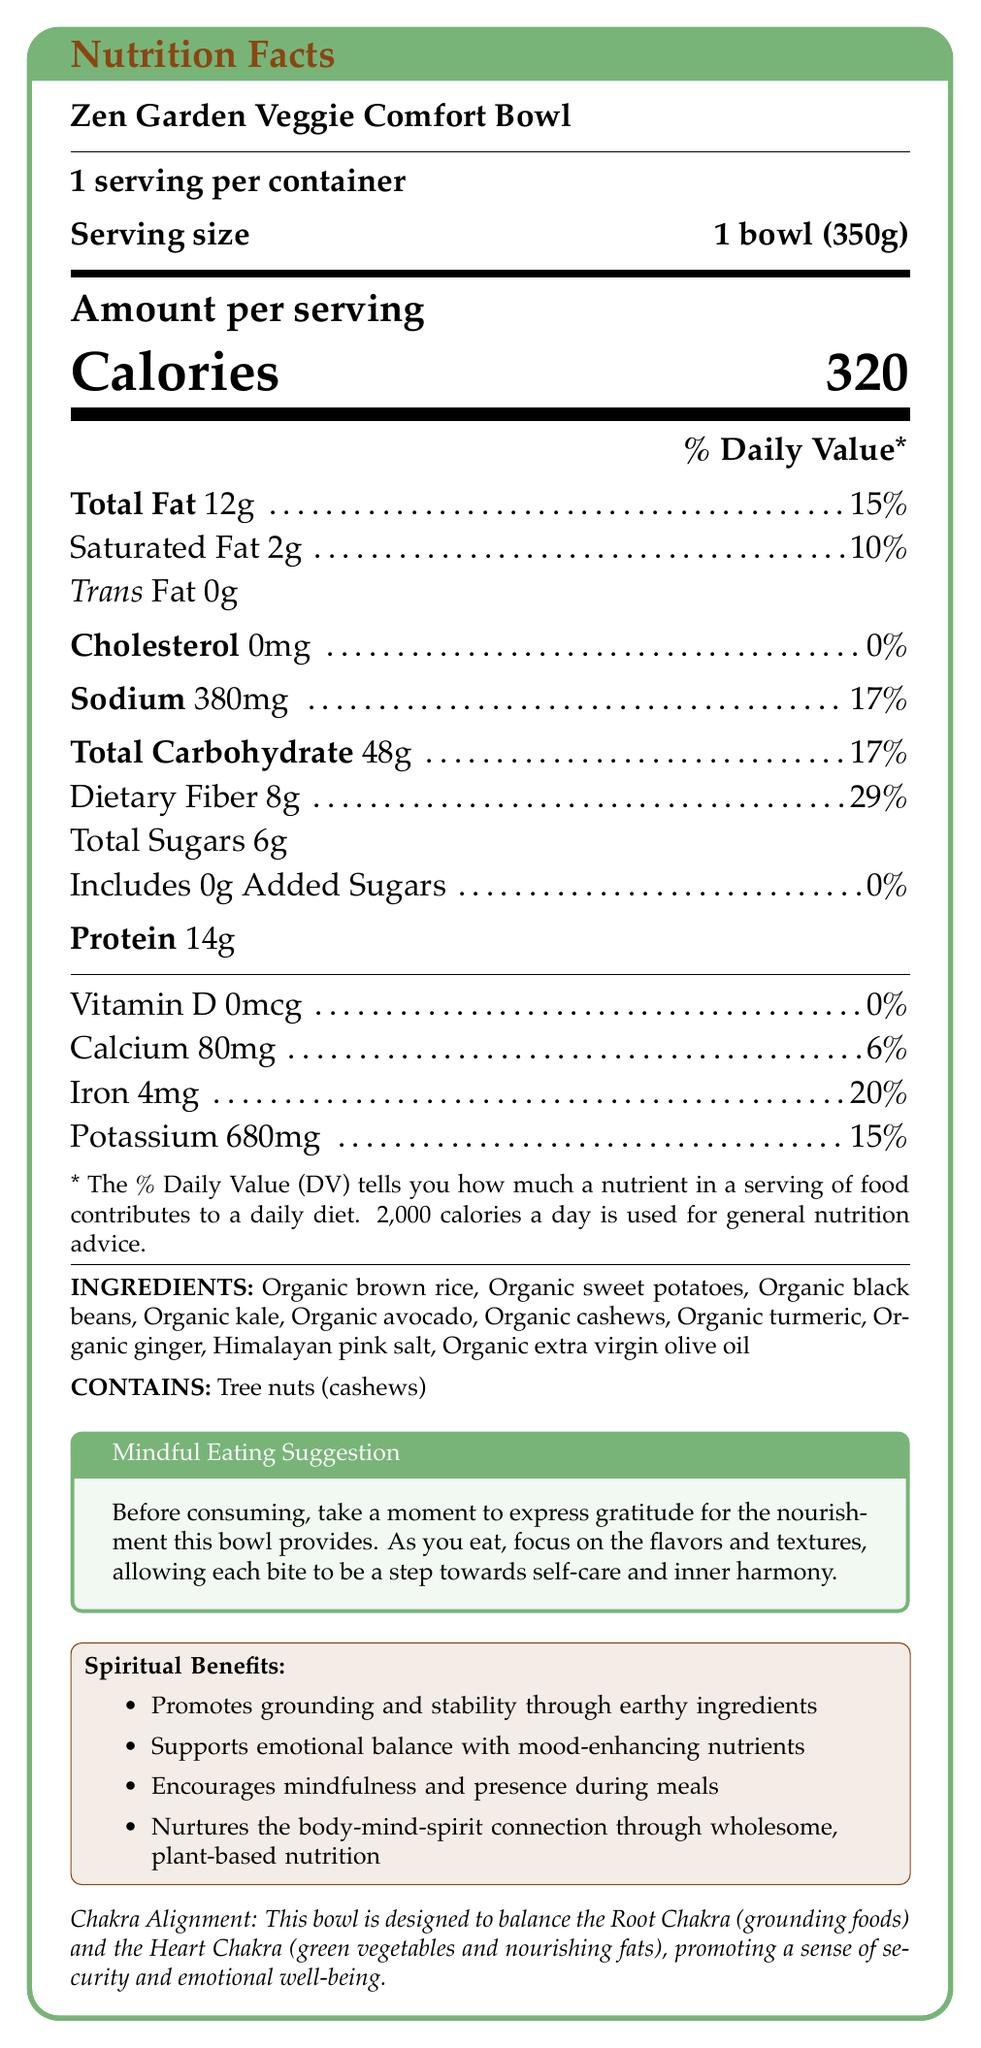How many calories are in one serving of the Zen Garden Veggie Comfort Bowl? The document states "Calories" followed by "320", which refers to the number of calories per serving.
Answer: 320 What is the serving size of the Zen Garden Veggie Comfort Bowl? The document specifies "Serving size: 1 bowl (350g)".
Answer: 1 bowl (350g) How much protein does one serving of this bowl provide? The document lists "Protein" followed by "14g".
Answer: 14g What percentage of the daily value of dietary fiber does one serving of the bowl provide? The document states "Dietary Fiber 8g" and indicates this is 29% of the daily value.
Answer: 29% Is there any cholesterol in the Zen Garden Veggie Comfort Bowl? The document says "Cholesterol 0mg" and "0%".
Answer: No Which ingredient in the bowl could cause an allergic reaction due to tree nut content? The document lists cashews under "INGREDIENTS" and mentions "Contains tree nuts (cashews)".
Answer: Organic cashews What are the two main chakras that this bowl is designed to balance? The document states that the bowl "is designed to balance the Root Chakra (grounding foods) and the Heart Chakra (green vegetables and nourishing fats)".
Answer: Root Chakra and Heart Chakra How much sodium is in one serving of the Zen Garden Veggie Comfort Bowl? The document specifies "Sodium 380mg".
Answer: 380mg Which of the following spiritual benefits is mentioned? A. Enhances physical strength B. Promotes grounding and stability C. Improves vision D. Increases intelligence The document lists among its spiritual benefits: "Promotes grounding and stability through earthy ingredients".
Answer: B Which of the following is NOT listed as a spiritual benefit? 1. Supports emotional balance 2. Nurtures the body-mind-spirit connection 3. Boosts immune system 4. Encourages mindfulness during meals The document does not mention "Boosts immune system" as a spiritual benefit, but it does mention the other three.
Answer: 3 Does the bowl contain added sugars? The document states "Includes 0g Added Sugars".
Answer: No Summarize the main idea of the document. The document describes the nutritional contents, ingredients, and spiritual benefits of the product, emphasizing its grounding and mood-enhancing properties to support emotional wellness and mindful eating.
Answer: The document provides the nutrition facts and highlights the spiritual and emotional benefits of the Zen Garden Veggie Comfort Bowl. It details its ingredients and their health benefits, aiming to support emotional healing and promote mindfulness. How is the bowl suggested to be consumed to promote mindfulness? The document suggests taking a moment to express gratitude and focusing on the flavors and textures to promote self-care and inner harmony.
Answer: Express gratitude for the nourishment and focus on the flavors and textures while eating. What percentage of the daily value of iron does the bowl provide? The document indicates "Iron 4mg" and "20%" of the daily value.
Answer: 20% Why might someone choose the Zen Garden Veggie Comfort Bowl as part of their diet? The document highlights that the bowl is a blend of wholesome ingredients designed to support emotional healing, promote inner peace, and encourage mindfulness during meals.
Answer: For its wholesome ingredients that promote emotional healing and inner peace, and as a mindful eating option. Is the Zen Garden Veggie Comfort Bowl gluten-free? The document does not provide any information regarding whether the bowl is gluten-free or not.
Answer: Cannot be determined 